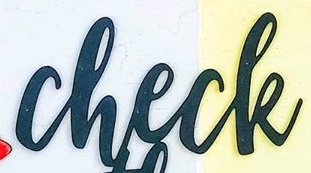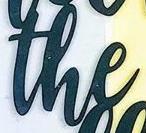Identify the words shown in these images in order, separated by a semicolon. check; the 